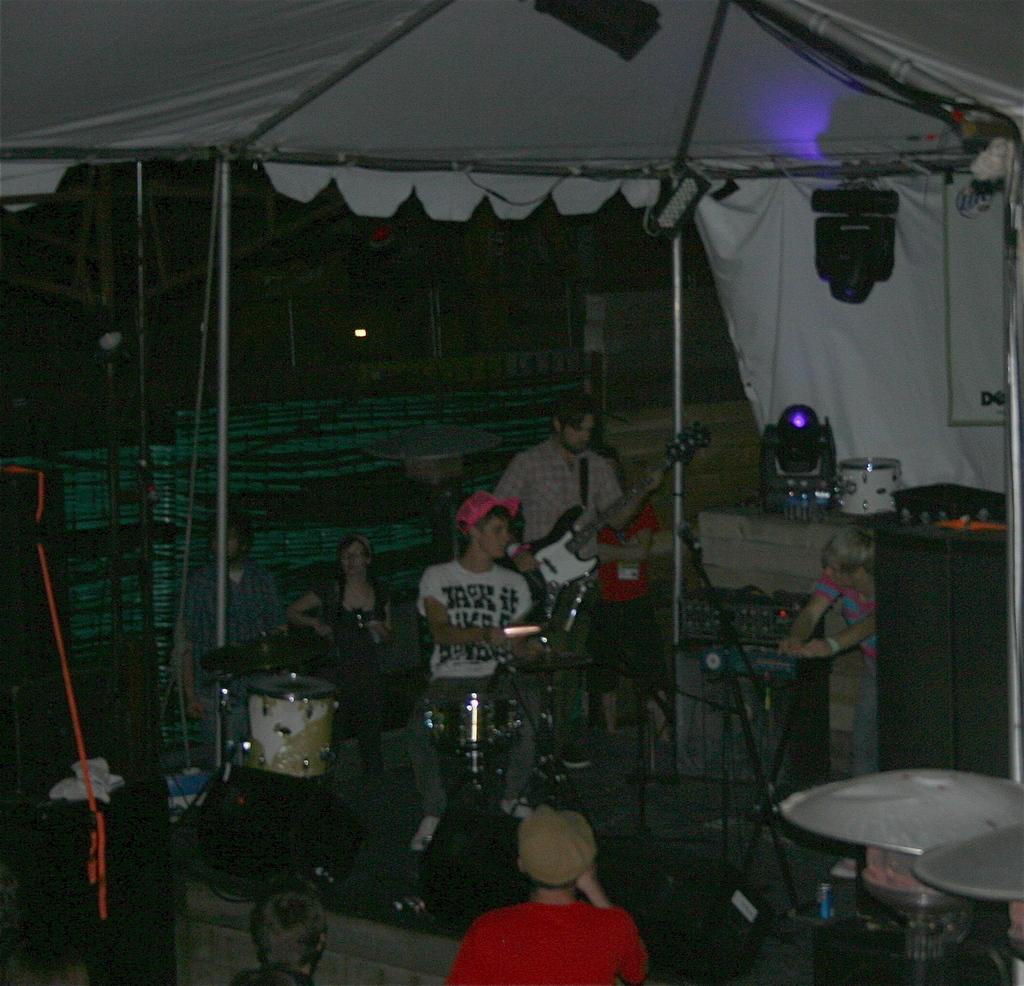In one or two sentences, can you explain what this image depicts? In this image, at the top there is a tent inside that there are some people, musical instruments and speaker. On the right there is a light. 